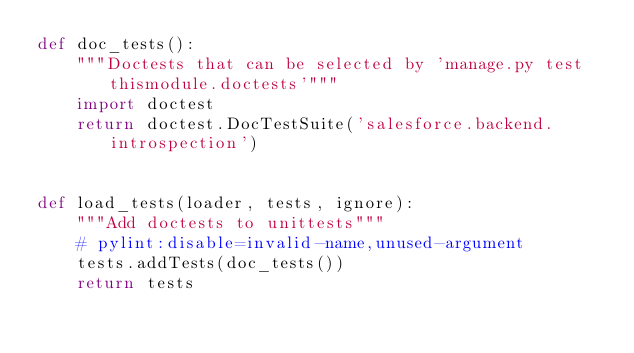<code> <loc_0><loc_0><loc_500><loc_500><_Python_>def doc_tests():
    """Doctests that can be selected by 'manage.py test thismodule.doctests'"""
    import doctest
    return doctest.DocTestSuite('salesforce.backend.introspection')


def load_tests(loader, tests, ignore):
    """Add doctests to unittests"""
    # pylint:disable=invalid-name,unused-argument
    tests.addTests(doc_tests())
    return tests
</code> 